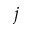<formula> <loc_0><loc_0><loc_500><loc_500>j</formula> 